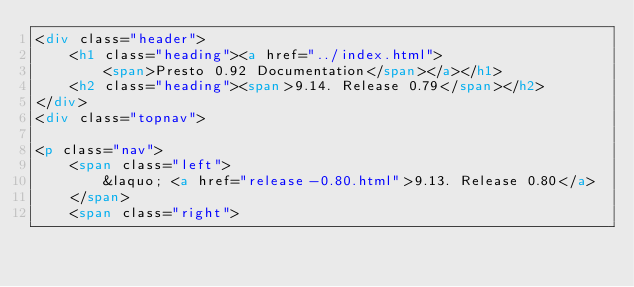Convert code to text. <code><loc_0><loc_0><loc_500><loc_500><_HTML_><div class="header">
    <h1 class="heading"><a href="../index.html">
        <span>Presto 0.92 Documentation</span></a></h1>
    <h2 class="heading"><span>9.14. Release 0.79</span></h2>
</div>
<div class="topnav">
    
<p class="nav">
    <span class="left">
        &laquo; <a href="release-0.80.html">9.13. Release 0.80</a>
    </span>
    <span class="right"></code> 